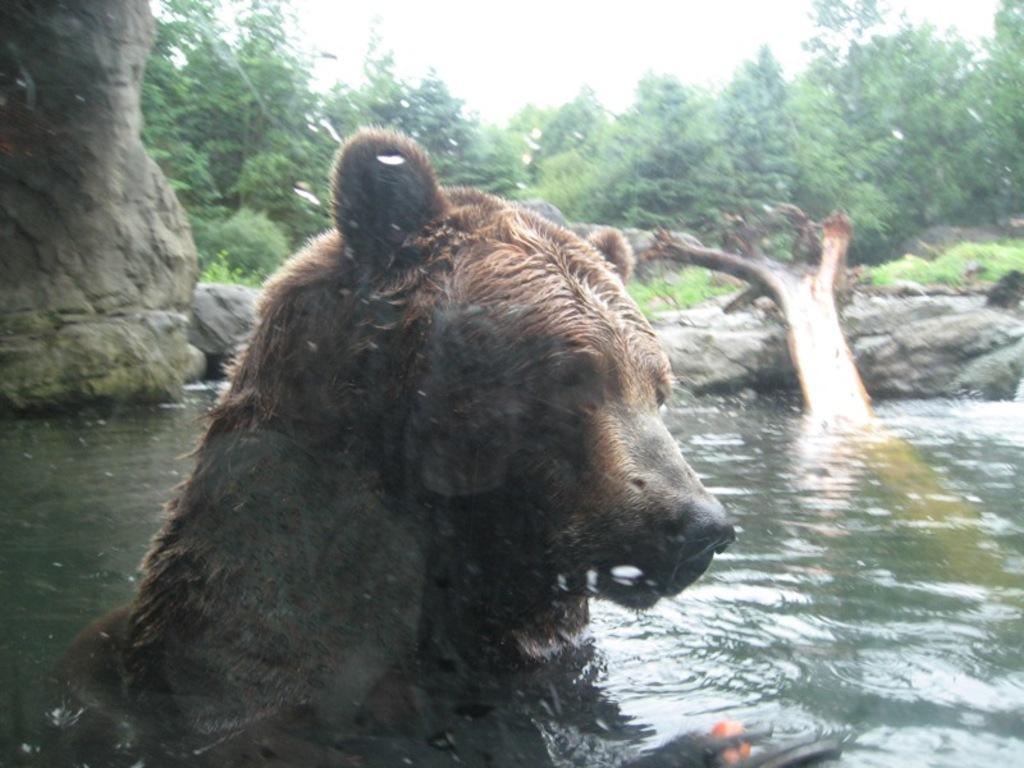Describe this image in one or two sentences. In the image we can see a bear in the water. Here we can see the wooden log, stones, trees, grass and the sky. 